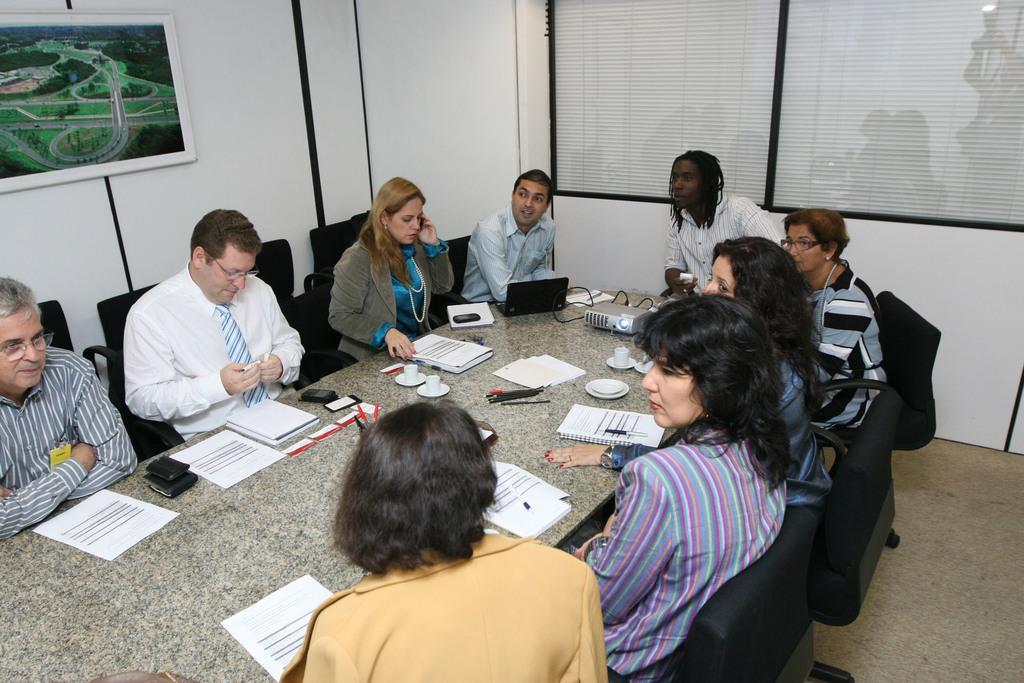Describe this image in one or two sentences. In this image I can see number of persons are sitting on chairs which are black in color around the table. On the table I can see few papers, few mobiles, a laptop which is black in color, a projector and few other objects. In the background I can see the wall and a photo frame attached to the wall. 